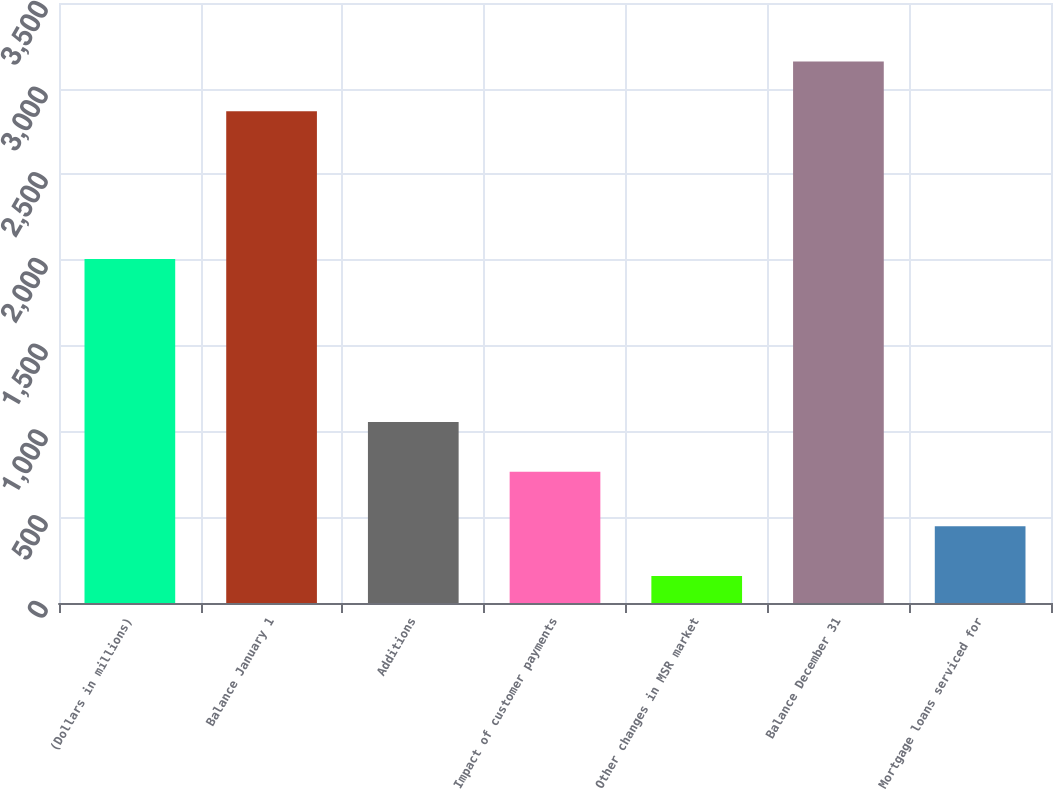<chart> <loc_0><loc_0><loc_500><loc_500><bar_chart><fcel>(Dollars in millions)<fcel>Balance January 1<fcel>Additions<fcel>Impact of customer payments<fcel>Other changes in MSR market<fcel>Balance December 31<fcel>Mortgage loans serviced for<nl><fcel>2007<fcel>2869<fcel>1055.5<fcel>766<fcel>158<fcel>3158.5<fcel>447.5<nl></chart> 